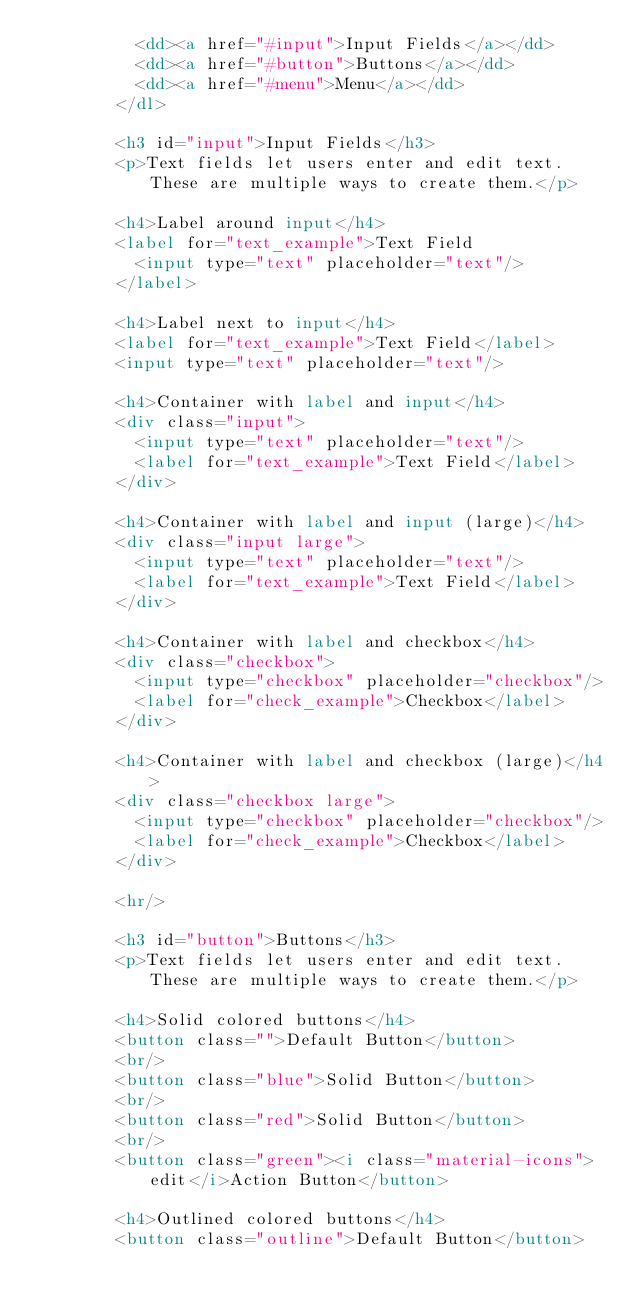<code> <loc_0><loc_0><loc_500><loc_500><_HTML_>          <dd><a href="#input">Input Fields</a></dd>
          <dd><a href="#button">Buttons</a></dd>
          <dd><a href="#menu">Menu</a></dd>
        </dl>

        <h3 id="input">Input Fields</h3>
        <p>Text fields let users enter and edit text.  These are multiple ways to create them.</p>

        <h4>Label around input</h4>
        <label for="text_example">Text Field
          <input type="text" placeholder="text"/>
        </label>

        <h4>Label next to input</h4>
        <label for="text_example">Text Field</label>
        <input type="text" placeholder="text"/>

        <h4>Container with label and input</h4>
        <div class="input">
          <input type="text" placeholder="text"/>
          <label for="text_example">Text Field</label>
        </div>

        <h4>Container with label and input (large)</h4>
        <div class="input large">
          <input type="text" placeholder="text"/>
          <label for="text_example">Text Field</label>
        </div>

        <h4>Container with label and checkbox</h4>
        <div class="checkbox">
          <input type="checkbox" placeholder="checkbox"/>
          <label for="check_example">Checkbox</label>
        </div>

        <h4>Container with label and checkbox (large)</h4>
        <div class="checkbox large">
          <input type="checkbox" placeholder="checkbox"/>
          <label for="check_example">Checkbox</label>
        </div>

        <hr/>

        <h3 id="button">Buttons</h3>
        <p>Text fields let users enter and edit text.  These are multiple ways to create them.</p>

        <h4>Solid colored buttons</h4>
        <button class="">Default Button</button>
        <br/>
        <button class="blue">Solid Button</button>
        <br/>
        <button class="red">Solid Button</button>
        <br/>
        <button class="green"><i class="material-icons">edit</i>Action Button</button>

        <h4>Outlined colored buttons</h4>
        <button class="outline">Default Button</button></code> 